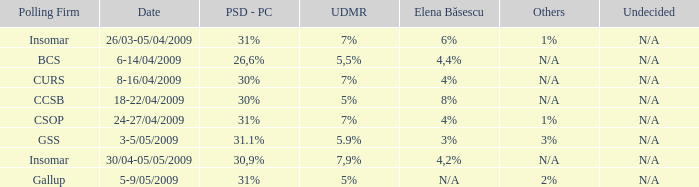What is the psd-pc for 18-22/04/2009? 30%. 